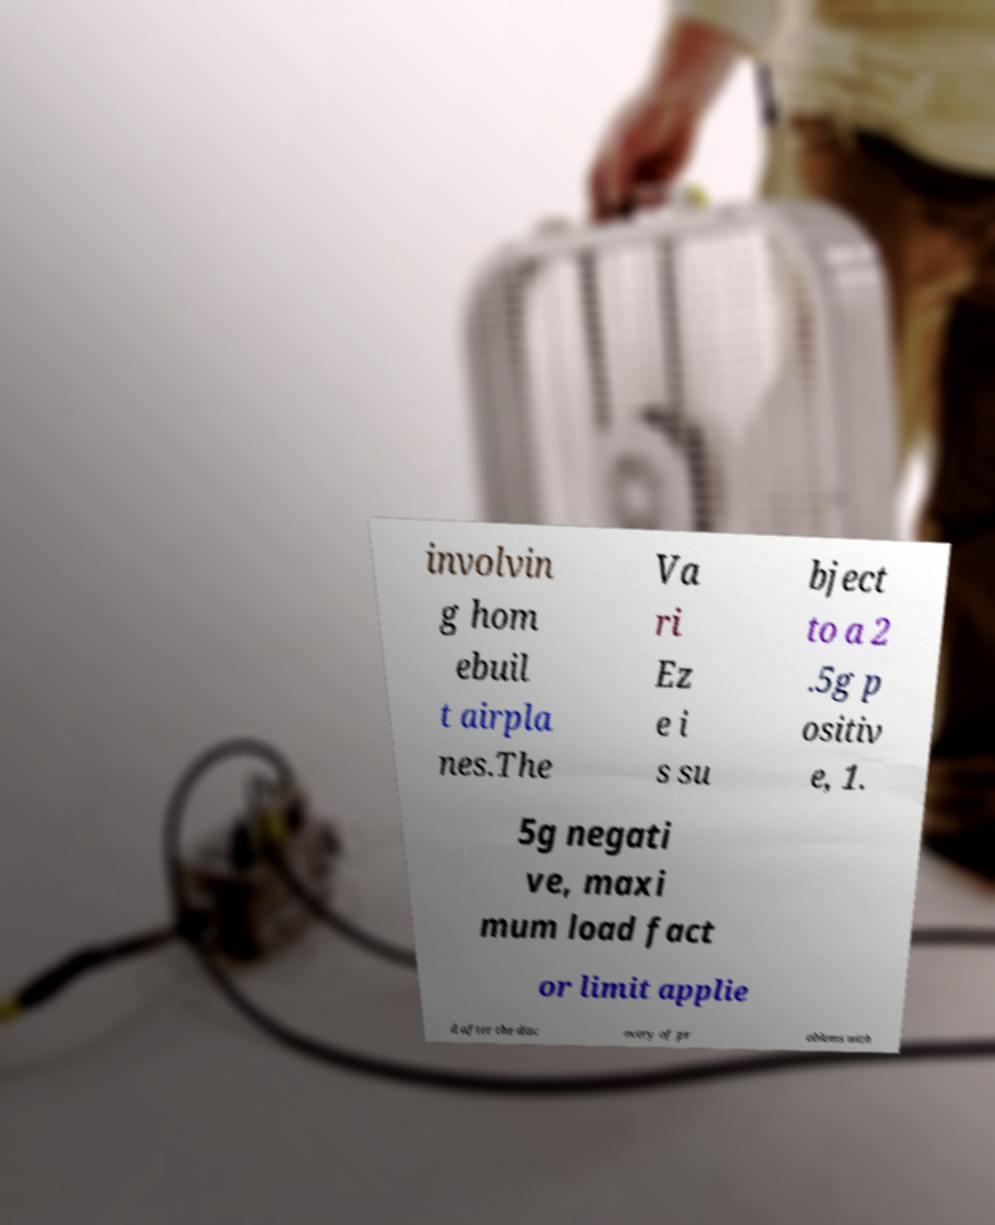Can you read and provide the text displayed in the image?This photo seems to have some interesting text. Can you extract and type it out for me? involvin g hom ebuil t airpla nes.The Va ri Ez e i s su bject to a 2 .5g p ositiv e, 1. 5g negati ve, maxi mum load fact or limit applie d after the disc overy of pr oblems with 